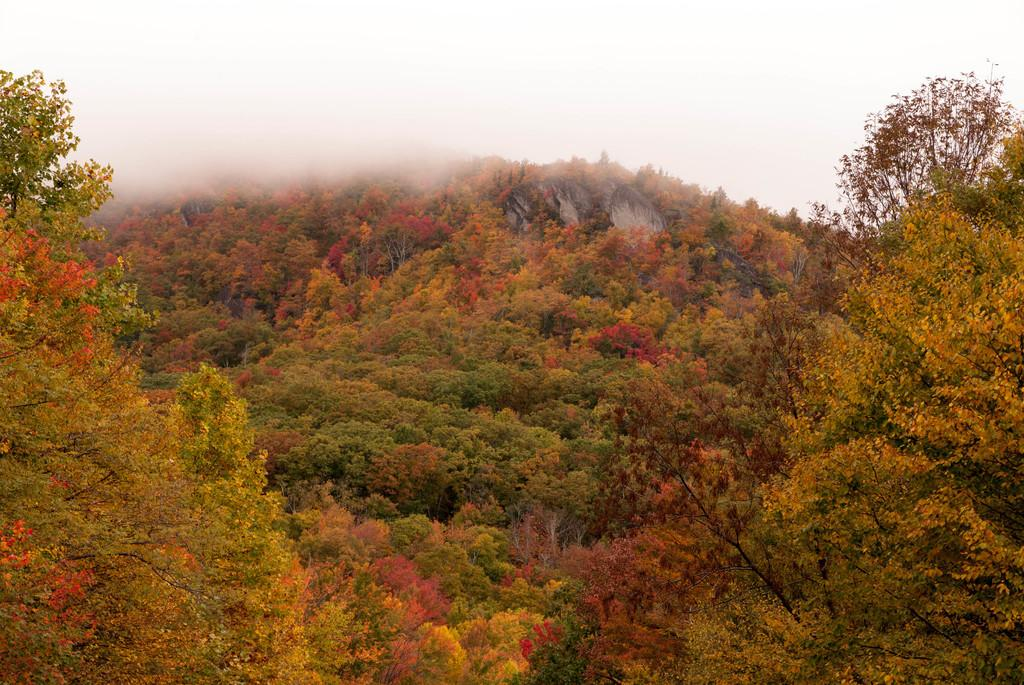Where was the image taken? The image was taken outdoors. What can be seen at the top of the image? The sky is visible at the top of the image. What is the main subject of the image? The main subject of the image is the trees. Can you describe the trees in the image? The trees have leaves, stems, flowers, and branches. What type of test is being conducted in the image? There is no test being conducted in the image; it features trees with leaves, stems, flowers, and branches. Whose birthday is being celebrated in the image? There is no birthday celebration depicted in the image; it focuses on trees in an outdoor setting. 